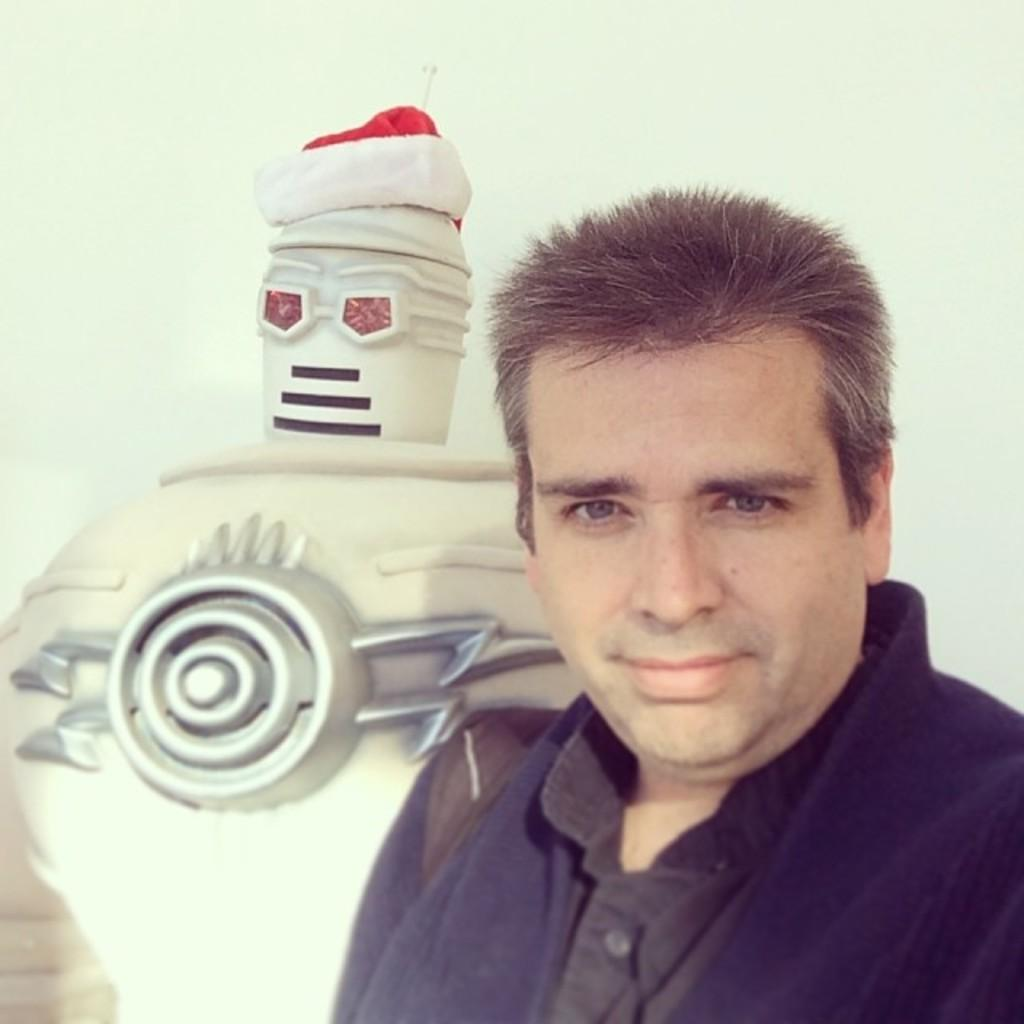Who is present in the image? There is a man in the image. What can be seen in the background of the image? There is a toy and a wall in the background of the image. Can you describe the toy in the image? The toy has a cap on it. What type of locket is the maid wearing in the image? There is no maid or locket present in the image. 